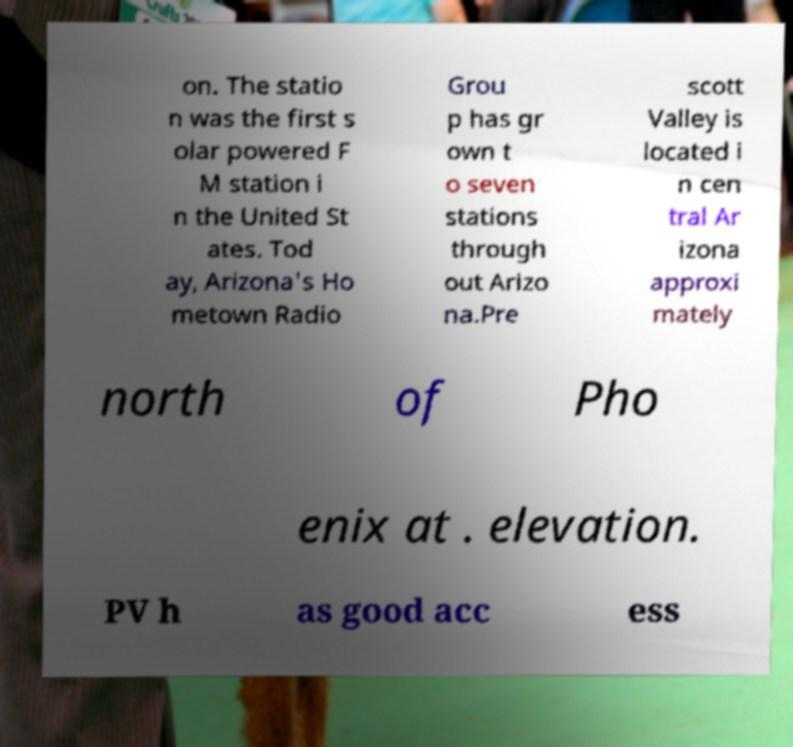I need the written content from this picture converted into text. Can you do that? on. The statio n was the first s olar powered F M station i n the United St ates. Tod ay, Arizona's Ho metown Radio Grou p has gr own t o seven stations through out Arizo na.Pre scott Valley is located i n cen tral Ar izona approxi mately north of Pho enix at . elevation. PV h as good acc ess 